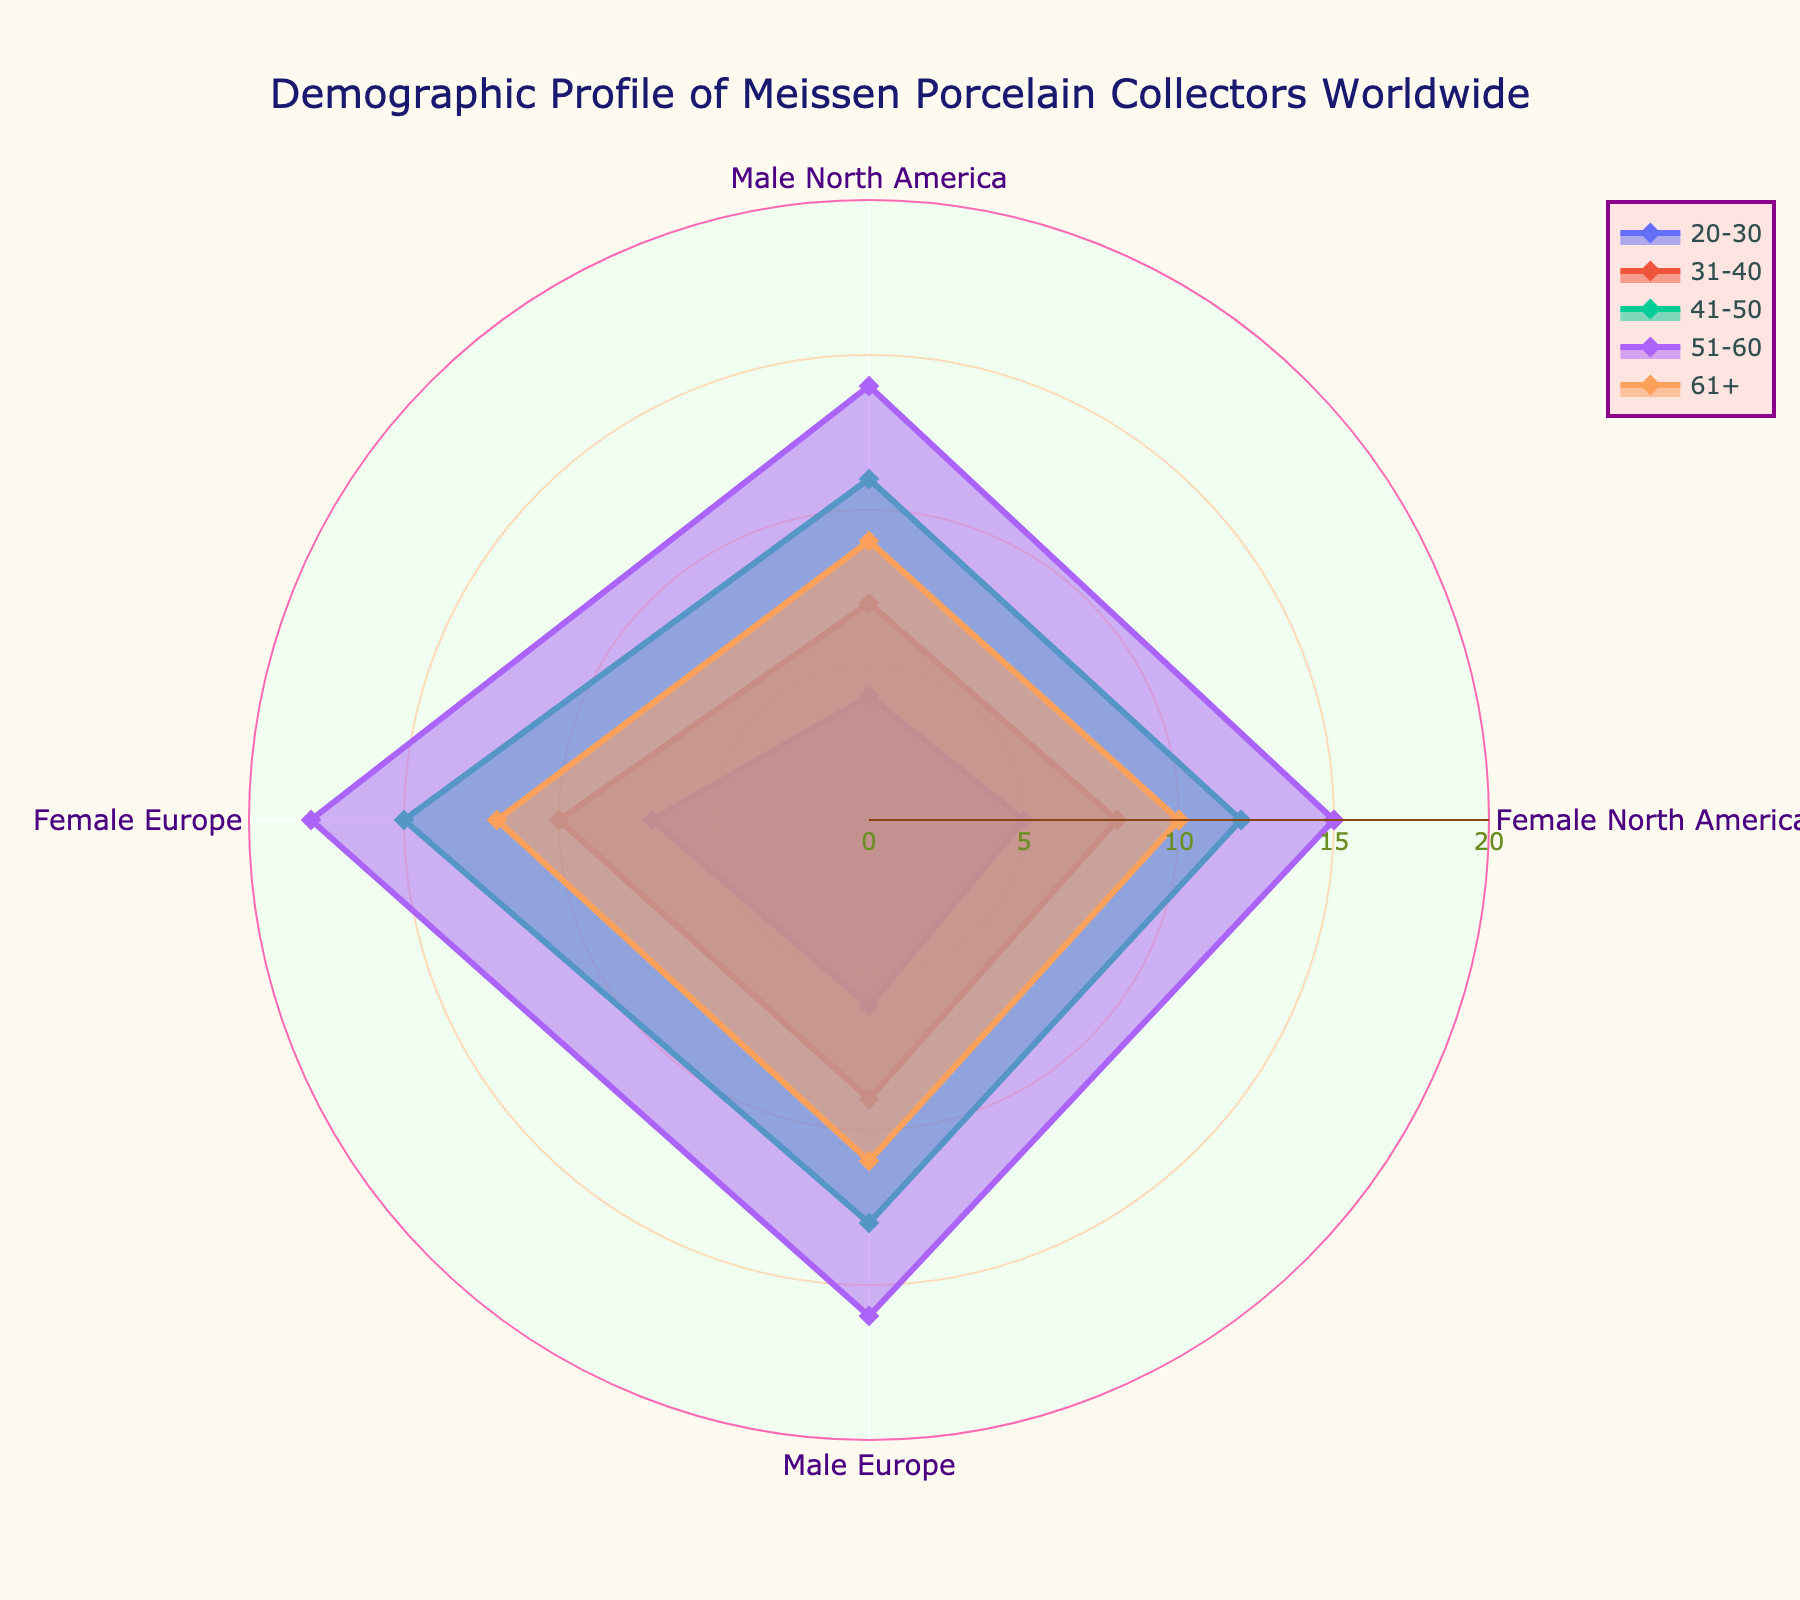what is the title of the radar chart? The title of the radar chart is displayed at the top center and is visually distinct due to its size and color.
Answer: Demographic Profile of Meissen Porcelain Collectors Worldwide Into how many regions do the "Female Europe" collectors range between ages 20-30? By looking at the radar chart, we count the specific portion for Female Europe aged 20-30, representing the European region.
Answer: 7 Which age group has the highest percentage of female collectors in Europe? We trace the radar chart segments labeled "Female Europe" and compare them across different age groups to find the maximum percentage value.
Answer: 51-60 What's the total percentage of male collectors in Europe for all age groups combined? We sum up the percentages for Male Europe across all age groups (6 + 9 + 13 + 16 + 11 = 55).
Answer: 55 How does the percentage of "Female North America" collectors in the 41-50 age group compare with "Male North America" collectors in the same age group? By examining the data and radar chart, we compare the respective values for this age group (Female North America: 12, Male North America: 11).
Answer: Female North America has 1% more collectors Which category shows more even distribution among all age groups, Male or Female categories in North America? By comparing the radar chart's patterns, we assess the consistency in percentages for Male and Female categories in North America across different age groups.
Answer: Male categories in North America show a more even distribution Identify the age group that has the lowest percentage of collectors for both "Female Europe" and "Male Europe" combined. We sum the percentages for each age group and identify the minimum combined value (20-30: 7 + 6 = 13, 31-40: 10 + 9 = 19, 41-50: 15 + 13 = 28, 51-60: 18 + 16 = 34, 61+: 12 + 11 = 23).
Answer: 20-30 What's the average percentage of Female collectors across all regions and age groups? We calculate the average by summing all Female percentages and dividing by the total number of groups ((5 + 7 + 8 + 10 + 12 + 15 + 10 + 12) / 8 = 10.375).
Answer: 10.375 